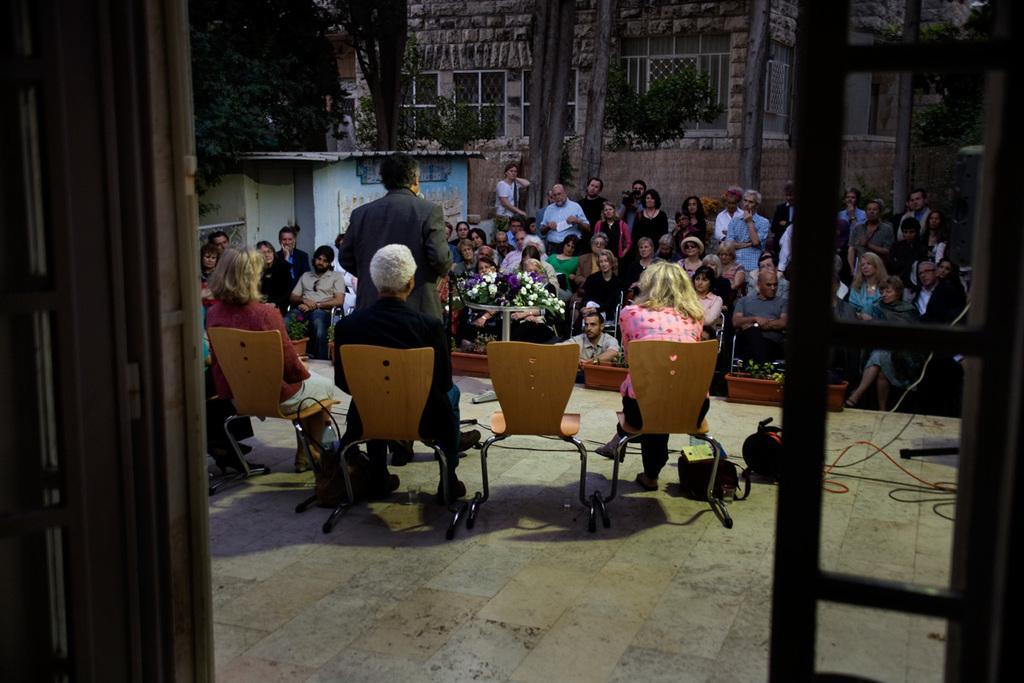Describe this image in one or two sentences. There are four members of the stage. Three of them were sitting and one guy standing and speaking in front of a podium. Many people in the dow was sitting and listening to this guy. In the background, there is a window, wall and some trees here. 